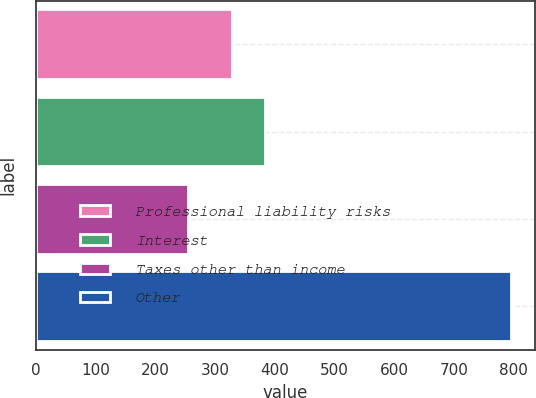Convert chart. <chart><loc_0><loc_0><loc_500><loc_500><bar_chart><fcel>Professional liability risks<fcel>Interest<fcel>Taxes other than income<fcel>Other<nl><fcel>329<fcel>383.1<fcel>255<fcel>796<nl></chart> 